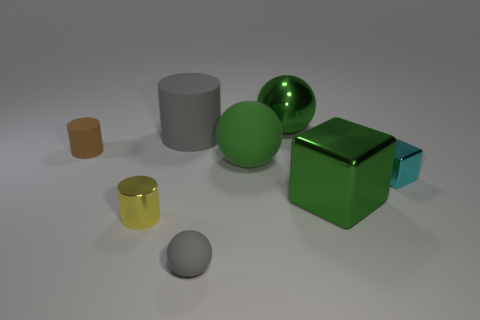Add 2 big metallic cubes. How many objects exist? 10 Subtract all cylinders. How many objects are left? 5 Subtract all tiny brown spheres. Subtract all green spheres. How many objects are left? 6 Add 5 cyan cubes. How many cyan cubes are left? 6 Add 6 big red things. How many big red things exist? 6 Subtract 0 blue cylinders. How many objects are left? 8 